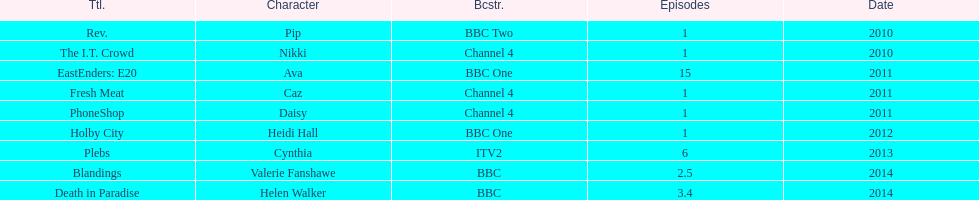What is the sole character she portrayed with broadcaster itv2? Cynthia. 